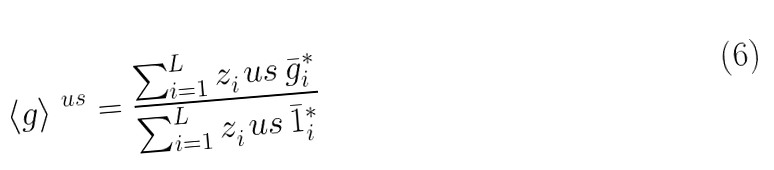Convert formula to latex. <formula><loc_0><loc_0><loc_500><loc_500>\langle g \rangle ^ { \ u s } = \frac { \sum _ { i = 1 } ^ { L } z _ { i } ^ { \ } u s \, \bar { g } ^ { \ast } _ { i } } { \sum _ { i = 1 } ^ { L } z _ { i } ^ { \ } u s \, \bar { 1 } ^ { \ast } _ { i } }</formula> 